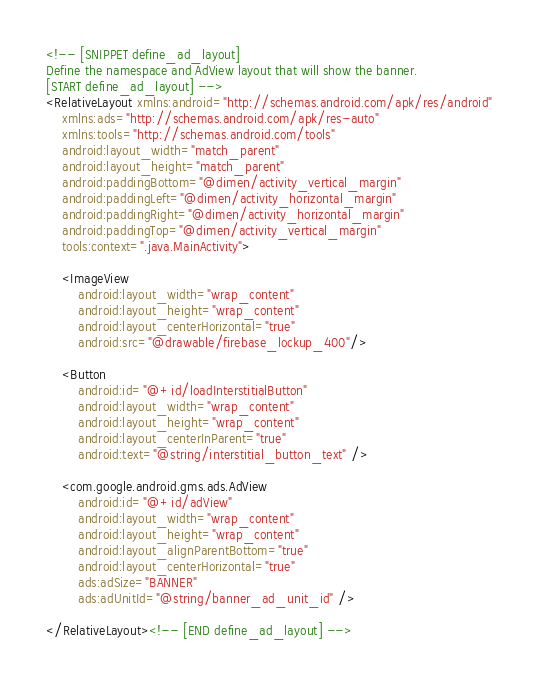Convert code to text. <code><loc_0><loc_0><loc_500><loc_500><_XML_><!-- [SNIPPET define_ad_layout]
Define the namespace and AdView layout that will show the banner.
[START define_ad_layout] -->
<RelativeLayout xmlns:android="http://schemas.android.com/apk/res/android"
    xmlns:ads="http://schemas.android.com/apk/res-auto"
    xmlns:tools="http://schemas.android.com/tools"
    android:layout_width="match_parent"
    android:layout_height="match_parent"
    android:paddingBottom="@dimen/activity_vertical_margin"
    android:paddingLeft="@dimen/activity_horizontal_margin"
    android:paddingRight="@dimen/activity_horizontal_margin"
    android:paddingTop="@dimen/activity_vertical_margin"
    tools:context=".java.MainActivity">

    <ImageView
        android:layout_width="wrap_content"
        android:layout_height="wrap_content"
        android:layout_centerHorizontal="true"
        android:src="@drawable/firebase_lockup_400"/>

    <Button
        android:id="@+id/loadInterstitialButton"
        android:layout_width="wrap_content"
        android:layout_height="wrap_content"
        android:layout_centerInParent="true"
        android:text="@string/interstitial_button_text" />

    <com.google.android.gms.ads.AdView
        android:id="@+id/adView"
        android:layout_width="wrap_content"
        android:layout_height="wrap_content"
        android:layout_alignParentBottom="true"
        android:layout_centerHorizontal="true"
        ads:adSize="BANNER"
        ads:adUnitId="@string/banner_ad_unit_id" />

</RelativeLayout><!-- [END define_ad_layout] -->
</code> 